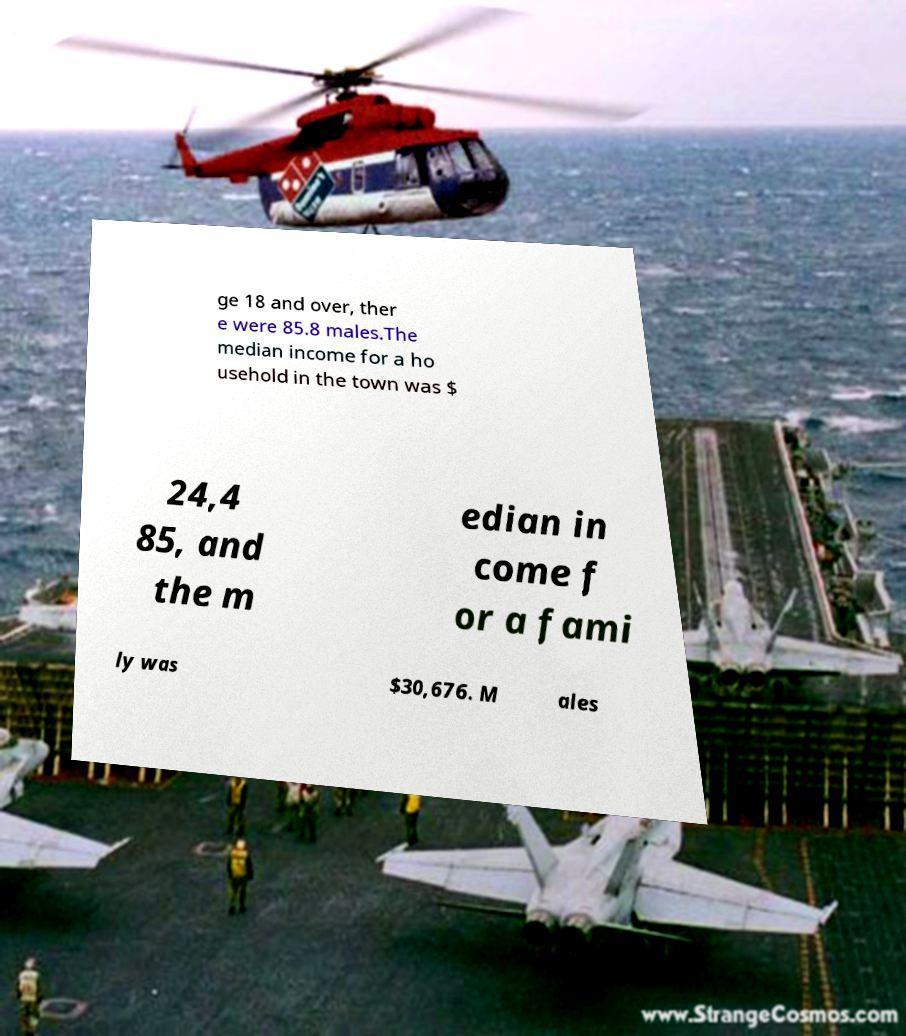Could you assist in decoding the text presented in this image and type it out clearly? ge 18 and over, ther e were 85.8 males.The median income for a ho usehold in the town was $ 24,4 85, and the m edian in come f or a fami ly was $30,676. M ales 